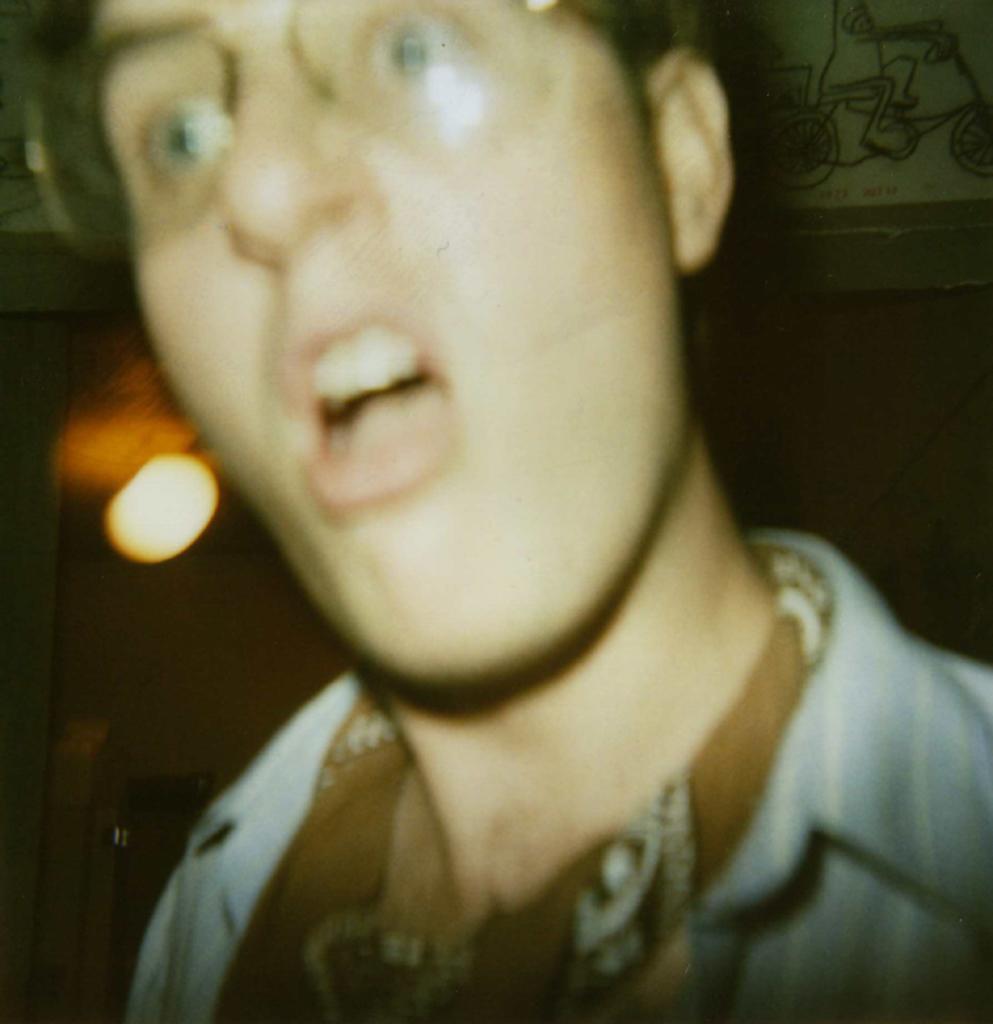In one or two sentences, can you explain what this image depicts? In this image, we can see a person standing, on the left side, we can see a light and we can see the wall. 